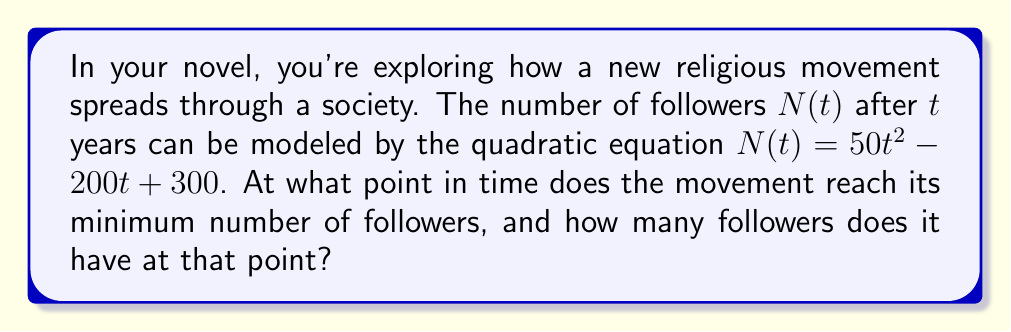Could you help me with this problem? To find the minimum point of a quadratic function, we need to follow these steps:

1) The general form of a quadratic equation is $f(t) = at^2 + bt + c$, where $a$, $b$, and $c$ are constants and $a \neq 0$.

2) In this case, we have $N(t) = 50t^2 - 200t + 300$, so $a = 50$, $b = -200$, and $c = 300$.

3) The t-coordinate of the vertex (minimum or maximum point) is given by the formula $t = -\frac{b}{2a}$.

4) Substituting our values:
   $$t = -\frac{-200}{2(50)} = \frac{200}{100} = 2$$

5) To find the number of followers at this point, we substitute $t = 2$ into our original equation:
   $$N(2) = 50(2)^2 - 200(2) + 300$$
   $$= 50(4) - 400 + 300$$
   $$= 200 - 400 + 300$$
   $$= 100$$

Therefore, the movement reaches its minimum number of followers after 2 years, with 100 followers at that point.
Answer: 2 years; 100 followers 